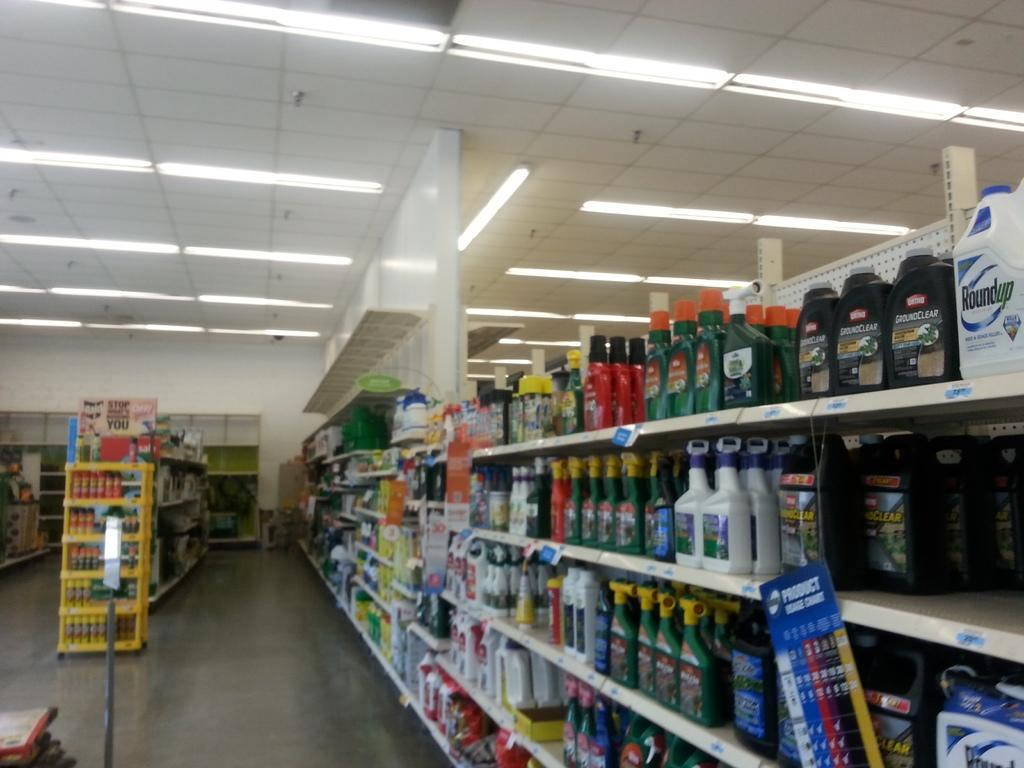<image>
Summarize the visual content of the image. Store asile that has roundup on top shelf 